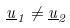Convert formula to latex. <formula><loc_0><loc_0><loc_500><loc_500>\underline { u } _ { 1 } \ne \underline { u } _ { 2 }</formula> 